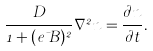Convert formula to latex. <formula><loc_0><loc_0><loc_500><loc_500>\frac { D } { 1 + ( e \mu B ) ^ { 2 } } \nabla ^ { 2 } n = \frac { \partial n } { \partial t } .</formula> 